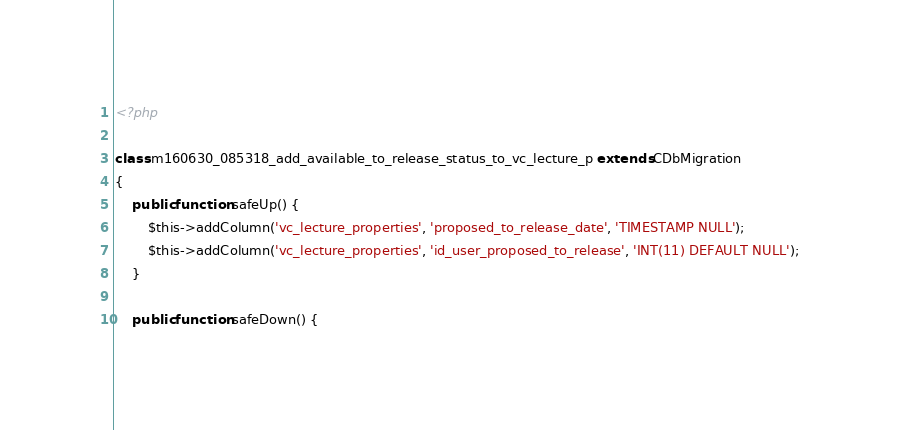<code> <loc_0><loc_0><loc_500><loc_500><_PHP_><?php

class m160630_085318_add_available_to_release_status_to_vc_lecture_p extends CDbMigration
{
	public function safeUp() {
		$this->addColumn('vc_lecture_properties', 'proposed_to_release_date', 'TIMESTAMP NULL');
		$this->addColumn('vc_lecture_properties', 'id_user_proposed_to_release', 'INT(11) DEFAULT NULL');
	}

	public function safeDown() {</code> 